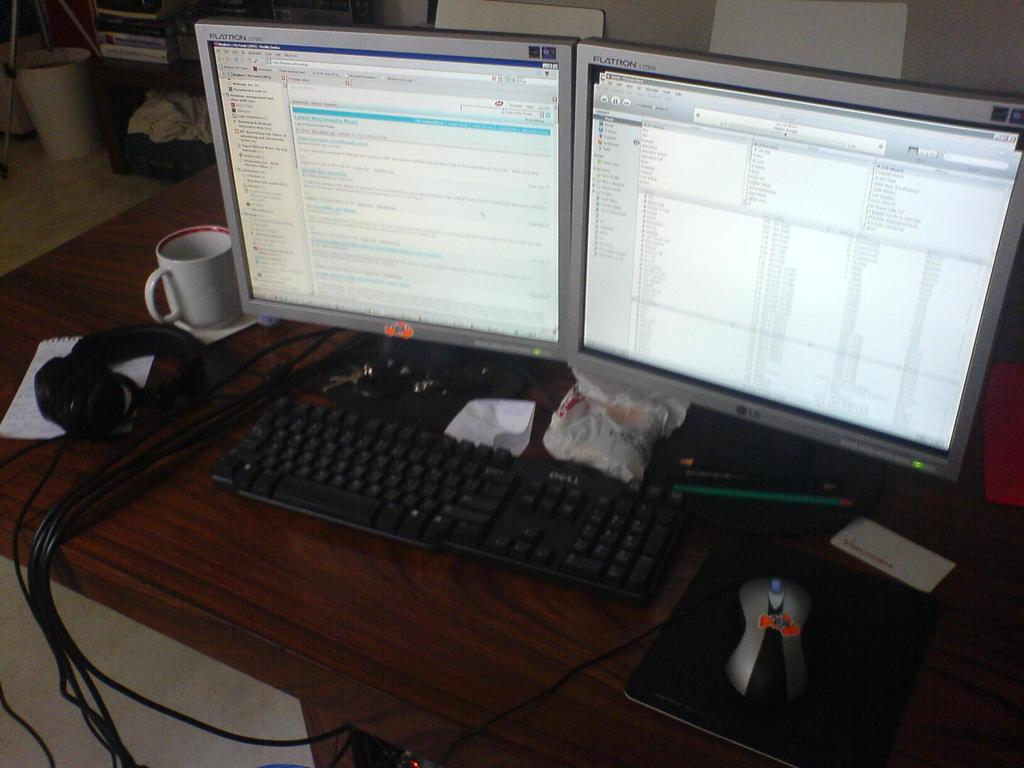<image>
Summarize the visual content of the image. Two Flatron screens sit together on a desk with a mug alongside. 